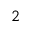<formula> <loc_0><loc_0><loc_500><loc_500>^ { 2 }</formula> 